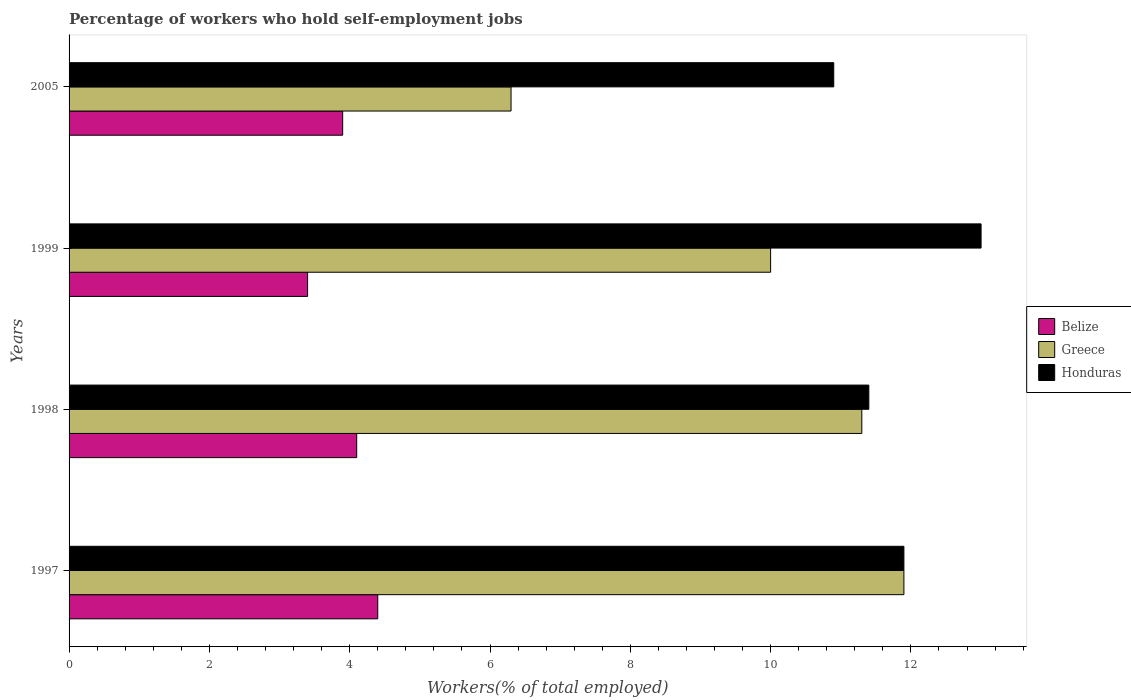How many different coloured bars are there?
Keep it short and to the point. 3. How many bars are there on the 2nd tick from the top?
Your response must be concise. 3. How many bars are there on the 2nd tick from the bottom?
Offer a very short reply. 3. What is the label of the 2nd group of bars from the top?
Make the answer very short. 1999. In how many cases, is the number of bars for a given year not equal to the number of legend labels?
Your response must be concise. 0. What is the percentage of self-employed workers in Belize in 1997?
Ensure brevity in your answer.  4.4. Across all years, what is the maximum percentage of self-employed workers in Greece?
Give a very brief answer. 11.9. Across all years, what is the minimum percentage of self-employed workers in Greece?
Keep it short and to the point. 6.3. In which year was the percentage of self-employed workers in Belize maximum?
Offer a very short reply. 1997. In which year was the percentage of self-employed workers in Honduras minimum?
Make the answer very short. 2005. What is the total percentage of self-employed workers in Honduras in the graph?
Ensure brevity in your answer.  47.2. What is the difference between the percentage of self-employed workers in Belize in 1997 and that in 1998?
Offer a terse response. 0.3. What is the difference between the percentage of self-employed workers in Honduras in 2005 and the percentage of self-employed workers in Belize in 1998?
Give a very brief answer. 6.8. What is the average percentage of self-employed workers in Belize per year?
Provide a short and direct response. 3.95. In the year 1998, what is the difference between the percentage of self-employed workers in Honduras and percentage of self-employed workers in Greece?
Your response must be concise. 0.1. In how many years, is the percentage of self-employed workers in Greece greater than 3.2 %?
Make the answer very short. 4. What is the ratio of the percentage of self-employed workers in Belize in 1998 to that in 2005?
Your answer should be compact. 1.05. Is the percentage of self-employed workers in Belize in 1998 less than that in 1999?
Provide a succinct answer. No. Is the difference between the percentage of self-employed workers in Honduras in 1997 and 1999 greater than the difference between the percentage of self-employed workers in Greece in 1997 and 1999?
Your response must be concise. No. What is the difference between the highest and the second highest percentage of self-employed workers in Belize?
Provide a short and direct response. 0.3. What is the difference between the highest and the lowest percentage of self-employed workers in Greece?
Give a very brief answer. 5.6. In how many years, is the percentage of self-employed workers in Belize greater than the average percentage of self-employed workers in Belize taken over all years?
Your answer should be compact. 2. What does the 3rd bar from the top in 1999 represents?
Make the answer very short. Belize. What does the 1st bar from the bottom in 1998 represents?
Offer a terse response. Belize. Is it the case that in every year, the sum of the percentage of self-employed workers in Honduras and percentage of self-employed workers in Greece is greater than the percentage of self-employed workers in Belize?
Ensure brevity in your answer.  Yes. Are all the bars in the graph horizontal?
Keep it short and to the point. Yes. How many years are there in the graph?
Offer a terse response. 4. What is the difference between two consecutive major ticks on the X-axis?
Your answer should be very brief. 2. Are the values on the major ticks of X-axis written in scientific E-notation?
Give a very brief answer. No. Does the graph contain grids?
Offer a very short reply. No. How are the legend labels stacked?
Ensure brevity in your answer.  Vertical. What is the title of the graph?
Keep it short and to the point. Percentage of workers who hold self-employment jobs. What is the label or title of the X-axis?
Offer a terse response. Workers(% of total employed). What is the Workers(% of total employed) of Belize in 1997?
Make the answer very short. 4.4. What is the Workers(% of total employed) of Greece in 1997?
Your answer should be very brief. 11.9. What is the Workers(% of total employed) in Honduras in 1997?
Keep it short and to the point. 11.9. What is the Workers(% of total employed) in Belize in 1998?
Your answer should be compact. 4.1. What is the Workers(% of total employed) in Greece in 1998?
Offer a very short reply. 11.3. What is the Workers(% of total employed) of Honduras in 1998?
Keep it short and to the point. 11.4. What is the Workers(% of total employed) in Belize in 1999?
Keep it short and to the point. 3.4. What is the Workers(% of total employed) of Belize in 2005?
Offer a terse response. 3.9. What is the Workers(% of total employed) in Greece in 2005?
Your answer should be compact. 6.3. What is the Workers(% of total employed) in Honduras in 2005?
Your answer should be very brief. 10.9. Across all years, what is the maximum Workers(% of total employed) in Belize?
Provide a short and direct response. 4.4. Across all years, what is the maximum Workers(% of total employed) of Greece?
Provide a succinct answer. 11.9. Across all years, what is the minimum Workers(% of total employed) of Belize?
Your answer should be compact. 3.4. Across all years, what is the minimum Workers(% of total employed) in Greece?
Your answer should be very brief. 6.3. Across all years, what is the minimum Workers(% of total employed) in Honduras?
Offer a very short reply. 10.9. What is the total Workers(% of total employed) in Belize in the graph?
Give a very brief answer. 15.8. What is the total Workers(% of total employed) of Greece in the graph?
Your answer should be compact. 39.5. What is the total Workers(% of total employed) in Honduras in the graph?
Ensure brevity in your answer.  47.2. What is the difference between the Workers(% of total employed) in Belize in 1997 and that in 1998?
Keep it short and to the point. 0.3. What is the difference between the Workers(% of total employed) in Greece in 1997 and that in 1998?
Your answer should be very brief. 0.6. What is the difference between the Workers(% of total employed) in Honduras in 1997 and that in 1998?
Offer a very short reply. 0.5. What is the difference between the Workers(% of total employed) of Greece in 1997 and that in 1999?
Ensure brevity in your answer.  1.9. What is the difference between the Workers(% of total employed) of Honduras in 1997 and that in 2005?
Provide a succinct answer. 1. What is the difference between the Workers(% of total employed) of Greece in 1998 and that in 1999?
Keep it short and to the point. 1.3. What is the difference between the Workers(% of total employed) in Greece in 1998 and that in 2005?
Offer a very short reply. 5. What is the difference between the Workers(% of total employed) in Honduras in 1998 and that in 2005?
Your answer should be very brief. 0.5. What is the difference between the Workers(% of total employed) of Belize in 1997 and the Workers(% of total employed) of Greece in 1999?
Your answer should be compact. -5.6. What is the difference between the Workers(% of total employed) in Belize in 1997 and the Workers(% of total employed) in Honduras in 1999?
Ensure brevity in your answer.  -8.6. What is the difference between the Workers(% of total employed) in Greece in 1997 and the Workers(% of total employed) in Honduras in 1999?
Your answer should be compact. -1.1. What is the difference between the Workers(% of total employed) in Belize in 1997 and the Workers(% of total employed) in Greece in 2005?
Offer a very short reply. -1.9. What is the difference between the Workers(% of total employed) in Belize in 1997 and the Workers(% of total employed) in Honduras in 2005?
Provide a succinct answer. -6.5. What is the difference between the Workers(% of total employed) of Belize in 1998 and the Workers(% of total employed) of Greece in 1999?
Provide a short and direct response. -5.9. What is the difference between the Workers(% of total employed) in Belize in 1998 and the Workers(% of total employed) in Honduras in 1999?
Provide a short and direct response. -8.9. What is the difference between the Workers(% of total employed) of Greece in 1998 and the Workers(% of total employed) of Honduras in 2005?
Your response must be concise. 0.4. What is the difference between the Workers(% of total employed) of Belize in 1999 and the Workers(% of total employed) of Greece in 2005?
Provide a succinct answer. -2.9. What is the difference between the Workers(% of total employed) of Belize in 1999 and the Workers(% of total employed) of Honduras in 2005?
Provide a succinct answer. -7.5. What is the average Workers(% of total employed) in Belize per year?
Offer a very short reply. 3.95. What is the average Workers(% of total employed) of Greece per year?
Offer a terse response. 9.88. In the year 1997, what is the difference between the Workers(% of total employed) of Belize and Workers(% of total employed) of Greece?
Offer a very short reply. -7.5. In the year 1998, what is the difference between the Workers(% of total employed) of Belize and Workers(% of total employed) of Greece?
Your answer should be compact. -7.2. In the year 1998, what is the difference between the Workers(% of total employed) in Belize and Workers(% of total employed) in Honduras?
Give a very brief answer. -7.3. In the year 1999, what is the difference between the Workers(% of total employed) in Belize and Workers(% of total employed) in Greece?
Ensure brevity in your answer.  -6.6. In the year 1999, what is the difference between the Workers(% of total employed) in Belize and Workers(% of total employed) in Honduras?
Provide a succinct answer. -9.6. In the year 1999, what is the difference between the Workers(% of total employed) in Greece and Workers(% of total employed) in Honduras?
Your response must be concise. -3. In the year 2005, what is the difference between the Workers(% of total employed) of Belize and Workers(% of total employed) of Greece?
Offer a terse response. -2.4. In the year 2005, what is the difference between the Workers(% of total employed) in Belize and Workers(% of total employed) in Honduras?
Provide a succinct answer. -7. In the year 2005, what is the difference between the Workers(% of total employed) in Greece and Workers(% of total employed) in Honduras?
Keep it short and to the point. -4.6. What is the ratio of the Workers(% of total employed) of Belize in 1997 to that in 1998?
Ensure brevity in your answer.  1.07. What is the ratio of the Workers(% of total employed) of Greece in 1997 to that in 1998?
Make the answer very short. 1.05. What is the ratio of the Workers(% of total employed) in Honduras in 1997 to that in 1998?
Give a very brief answer. 1.04. What is the ratio of the Workers(% of total employed) of Belize in 1997 to that in 1999?
Ensure brevity in your answer.  1.29. What is the ratio of the Workers(% of total employed) of Greece in 1997 to that in 1999?
Your answer should be very brief. 1.19. What is the ratio of the Workers(% of total employed) of Honduras in 1997 to that in 1999?
Offer a terse response. 0.92. What is the ratio of the Workers(% of total employed) in Belize in 1997 to that in 2005?
Your answer should be compact. 1.13. What is the ratio of the Workers(% of total employed) in Greece in 1997 to that in 2005?
Offer a terse response. 1.89. What is the ratio of the Workers(% of total employed) in Honduras in 1997 to that in 2005?
Make the answer very short. 1.09. What is the ratio of the Workers(% of total employed) of Belize in 1998 to that in 1999?
Your answer should be very brief. 1.21. What is the ratio of the Workers(% of total employed) of Greece in 1998 to that in 1999?
Provide a succinct answer. 1.13. What is the ratio of the Workers(% of total employed) in Honduras in 1998 to that in 1999?
Give a very brief answer. 0.88. What is the ratio of the Workers(% of total employed) of Belize in 1998 to that in 2005?
Your answer should be very brief. 1.05. What is the ratio of the Workers(% of total employed) of Greece in 1998 to that in 2005?
Offer a very short reply. 1.79. What is the ratio of the Workers(% of total employed) of Honduras in 1998 to that in 2005?
Make the answer very short. 1.05. What is the ratio of the Workers(% of total employed) of Belize in 1999 to that in 2005?
Keep it short and to the point. 0.87. What is the ratio of the Workers(% of total employed) of Greece in 1999 to that in 2005?
Provide a succinct answer. 1.59. What is the ratio of the Workers(% of total employed) of Honduras in 1999 to that in 2005?
Offer a terse response. 1.19. What is the difference between the highest and the second highest Workers(% of total employed) of Greece?
Keep it short and to the point. 0.6. What is the difference between the highest and the lowest Workers(% of total employed) of Belize?
Your response must be concise. 1. What is the difference between the highest and the lowest Workers(% of total employed) of Honduras?
Offer a very short reply. 2.1. 